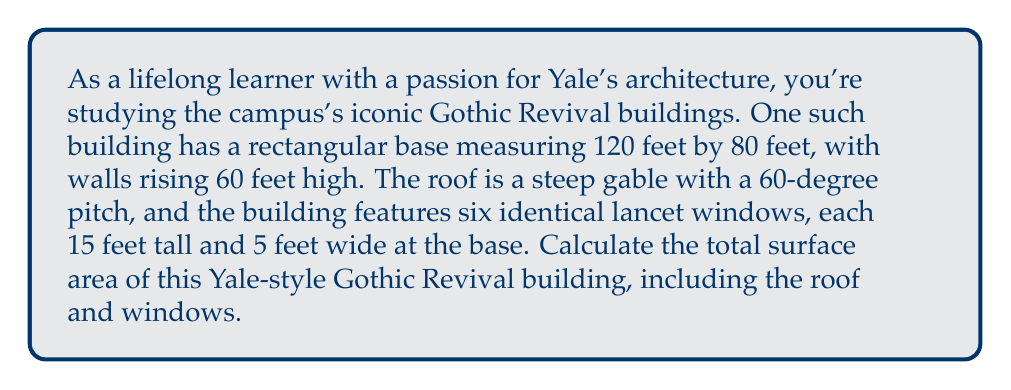What is the answer to this math problem? Let's break this problem down step-by-step:

1. Calculate the area of the walls:
   - Front and back walls: $2 \times (120 \text{ ft} \times 60 \text{ ft}) = 14,400 \text{ ft}^2$
   - Side walls: $2 \times (80 \text{ ft} \times 60 \text{ ft}) = 9,600 \text{ ft}^2$
   - Total wall area: $14,400 \text{ ft}^2 + 9,600 \text{ ft}^2 = 24,000 \text{ ft}^2$

2. Calculate the area of the roof:
   - The roof pitch is 60°, so we need to find the slant height using trigonometry
   - Half the width of the building is 40 ft (80 ft ÷ 2)
   - Slant height = $40 \text{ ft} \div \cos(60°) \approx 80 \text{ ft}$
   - Area of one side of the roof: $120 \text{ ft} \times 80 \text{ ft} = 9,600 \text{ ft}^2$
   - Total roof area: $2 \times 9,600 \text{ ft}^2 = 19,200 \text{ ft}^2$

3. Calculate the area of the windows:
   - Area of one window: $15 \text{ ft} \times 5 \text{ ft} = 75 \text{ ft}^2$
   - Total window area: $6 \times 75 \text{ ft}^2 = 450 \text{ ft}^2$

4. Subtract the window area from the wall area:
   - Adjusted wall area: $24,000 \text{ ft}^2 - 450 \text{ ft}^2 = 23,550 \text{ ft}^2$

5. Sum up the total surface area:
   - Total surface area = Adjusted wall area + Roof area
   - Total surface area = $23,550 \text{ ft}^2 + 19,200 \text{ ft}^2 = 42,750 \text{ ft}^2$

[asy]
import geometry;

size(200);

pair A = (0,0), B = (120,0), C = (120,60), D = (0,60);
pair E = (60,110);

draw(A--B--C--D--cycle);
draw(C--E--D);

label("120 ft", (60,0), S);
label("60 ft", (0,30), W);
label("80 ft", (60,110), N);

draw((55,0)--(55,60), dashed);
draw((65,0)--(65,60), dashed);

label("60°", (62,62), NE);
[/asy]
Answer: $$42,750 \text{ ft}^2$$ 